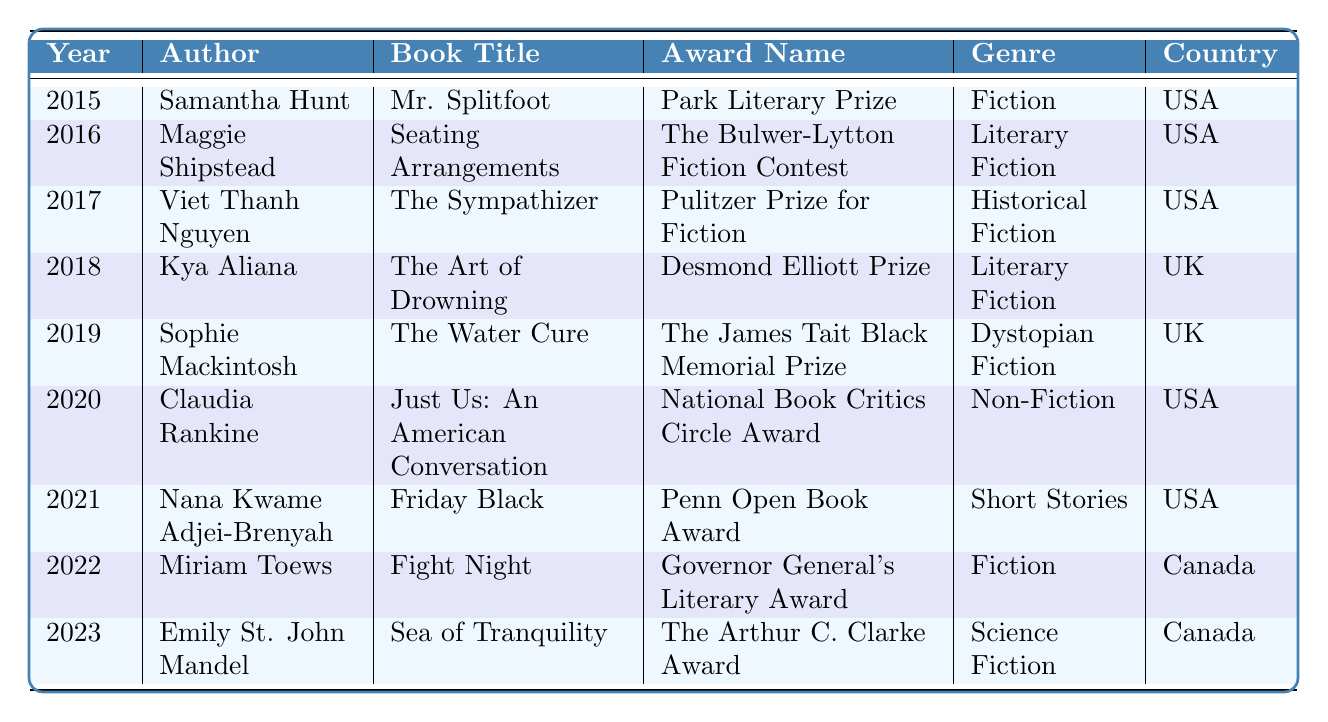What award did Samantha Hunt win in 2015? The table shows that in 2015, Samantha Hunt won the Park Literary Prize for her book "Mr. Splitfoot."
Answer: Park Literary Prize Which author won an award in 2020? According to the table, Claudia Rankine won an award in 2020 for her book "Just Us: An American Conversation."
Answer: Claudia Rankine How many authors in the table are from the USA? By counting the entries, we find that there are five authors from the USA (Samantha Hunt, Maggie Shipstead, Viet Thanh Nguyen, Claudia Rankine, and Nana Kwame Adjei-Brenyah).
Answer: 5 What genre does Emily St. John Mandel's book belong to? The table indicates that Emily St. John Mandel's book "Sea of Tranquility" belongs to the Science Fiction genre.
Answer: Science Fiction Which year saw the most recent award winner? The most recent award winner in the table is from 2023, with Emily St. John Mandel winning the award for "Sea of Tranquility."
Answer: 2023 Which author won the Pulitzer Prize for Fiction? The entry for 2017 shows that Viet Thanh Nguyen won the Pulitzer Prize for Fiction for his book "The Sympathizer."
Answer: Viet Thanh Nguyen Is there any author from Canada who won an award for Fiction? Yes, Miriam Toews is recorded in the table as the author from Canada who won the Governor General's Literary Award for her book "Fight Night," which falls under the Fiction genre.
Answer: Yes What is the average year of the awards listed? To calculate the average year, sum the years from 2015 to 2023 (2015 + 2016 + 2017 + 2018 + 2019 + 2020 + 2021 + 2022 + 2023 = 1820) and divide by the number of entries (9); 1820 / 9 = approximately 2022.22. Rounding gives us 2022.
Answer: 2022 Which genre had the most authors winning awards in this period? By examining the entries, we see that there are two authors each representing Fiction, Literary Fiction, and two more distinct genres (Non-Fiction, Dystopian Fiction). Fiction and Literary Fiction tie for the most authors with two entries each.
Answer: Fiction and Literary Fiction How many total different awards were given from 2015 to 2023 according to the table? The table lists 9 different entries, and each entry corresponds to a unique award. Therefore, a total of 9 awards were given.
Answer: 9 